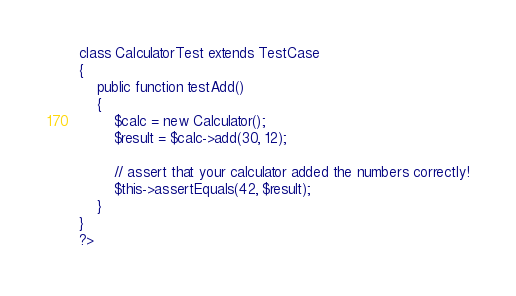Convert code to text. <code><loc_0><loc_0><loc_500><loc_500><_PHP_>class CalculatorTest extends TestCase
{
	public function testAdd()
	{
		$calc = new Calculator();
		$result = $calc->add(30, 12);
		
		// assert that your calculator added the numbers correctly!
		$this->assertEquals(42, $result);
	}
}
?></code> 